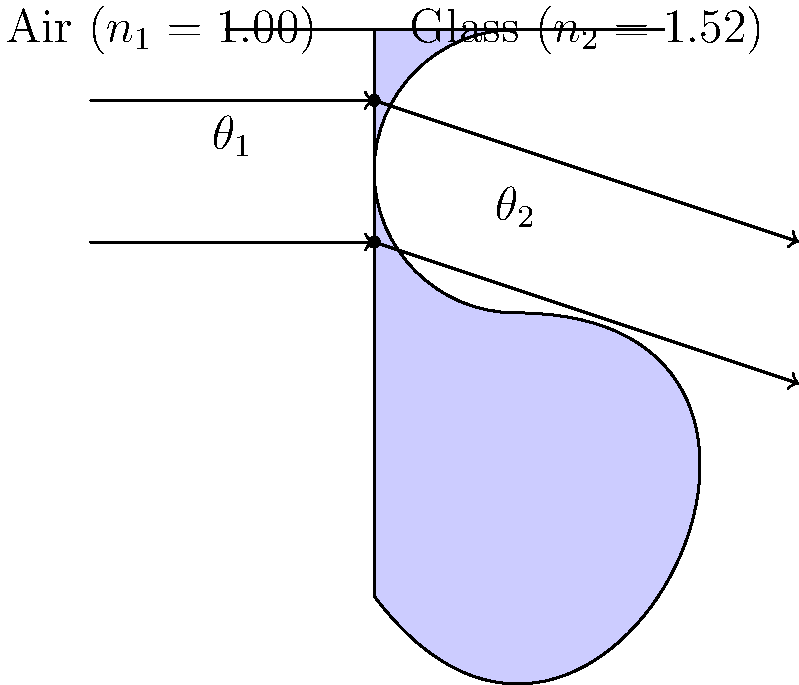As a film producer, you're working on a project that involves underwater cinematography. You're using a specialized camera lens made of glass with a refractive index of 1.52. If light enters the lens from air (refractive index 1.00) at an angle of 30° to the normal, what is the angle of refraction inside the glass lens? How might this affect your underwater shots? To solve this problem, we'll use Snell's law, which describes the relationship between the angles of incidence and refraction for light passing through different media:

$$n_1 \sin(\theta_1) = n_2 \sin(\theta_2)$$

Where:
$n_1$ = refractive index of air (1.00)
$n_2$ = refractive index of glass (1.52)
$\theta_1$ = angle of incidence (30°)
$\theta_2$ = angle of refraction (unknown)

Step 1: Substitute the known values into Snell's law:
$$(1.00) \sin(30°) = (1.52) \sin(\theta_2)$$

Step 2: Solve for $\sin(\theta_2)$:
$$\sin(\theta_2) = \frac{(1.00) \sin(30°)}{1.52}$$

Step 3: Calculate the value of $\sin(\theta_2)$:
$$\sin(\theta_2) = \frac{1.00 \times 0.5}{1.52} \approx 0.3289$$

Step 4: Find $\theta_2$ using the inverse sine function:
$$\theta_2 = \arcsin(0.3289) \approx 19.2°$$

This refraction will affect underwater shots by:
1. Reducing the apparent field of view underwater.
2. Causing objects to appear closer and larger than they actually are.
3. Potentially introducing chromatic aberration due to different wavelengths of light refracting at slightly different angles.

As a film producer, you might need to adjust your shooting techniques or use specialized underwater housing to compensate for these effects.
Answer: 19.2° 